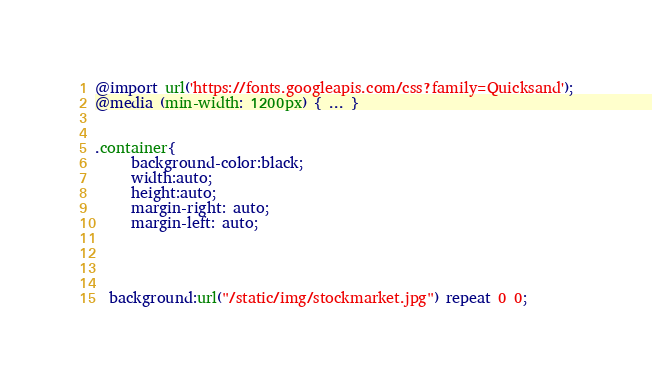Convert code to text. <code><loc_0><loc_0><loc_500><loc_500><_CSS_>@import url('https://fonts.googleapis.com/css?family=Quicksand');
@media (min-width: 1200px) { ... }


.container{
	 background-color:black;
	 width:auto;
	 height:auto;
	 margin-right: auto;
     margin-left: auto;
     
     
     
	 
  background:url("/static/img/stockmarket.jpg") repeat 0 0;</code> 